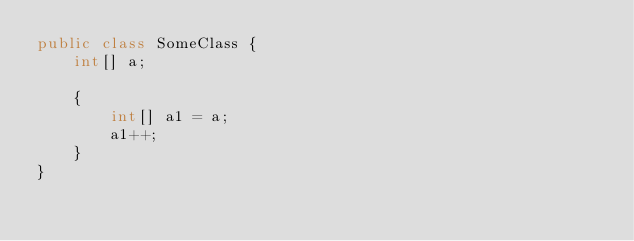<code> <loc_0><loc_0><loc_500><loc_500><_Java_>public class SomeClass {
    int[] a;
    
    {
        int[] a1 = a;
        a1++;
    }
}</code> 